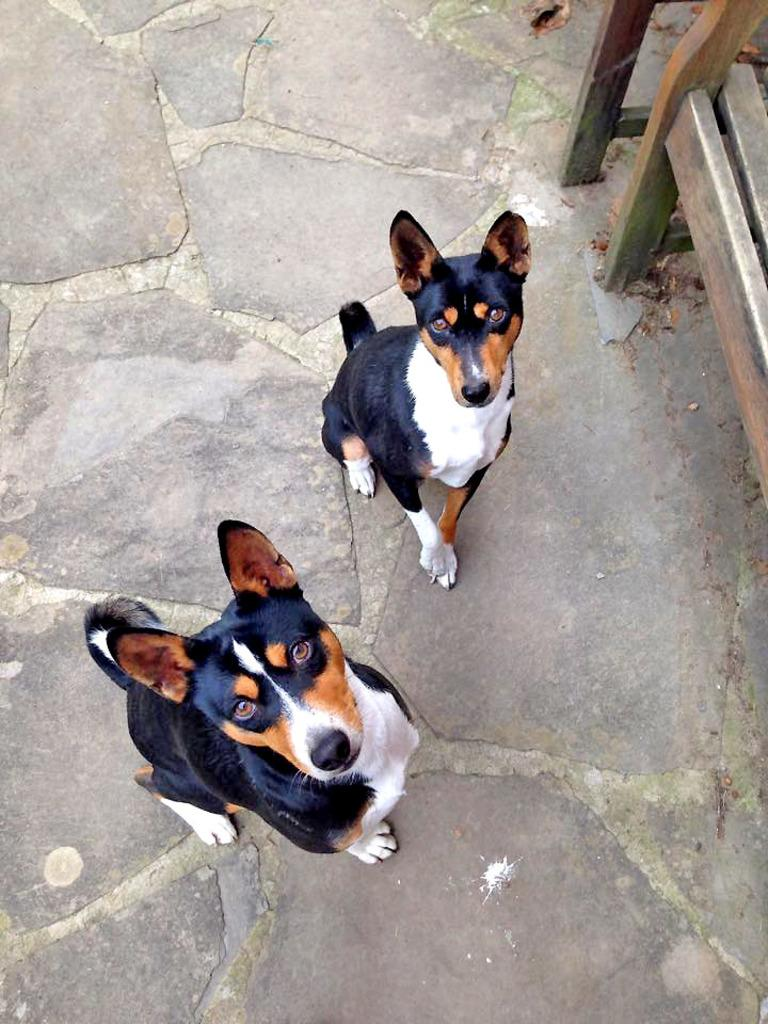How many dogs are present in the image? There are two dogs in the image. Where are the dogs located? The dogs are on the ground. What type of objects can be seen in the image besides the dogs? There are wooden objects in the image. How many giants are visible in the image? There are no giants present in the image. What type of spiders can be seen interacting with the wooden objects in the image? There are no spiders present in the image; it only features two dogs and wooden objects. 